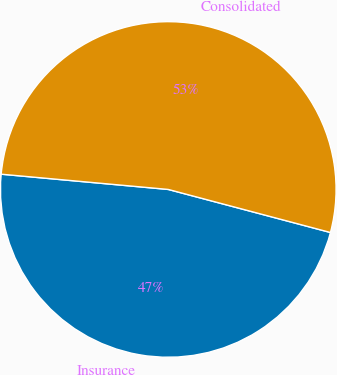<chart> <loc_0><loc_0><loc_500><loc_500><pie_chart><fcel>Insurance<fcel>Consolidated<nl><fcel>47.32%<fcel>52.68%<nl></chart> 